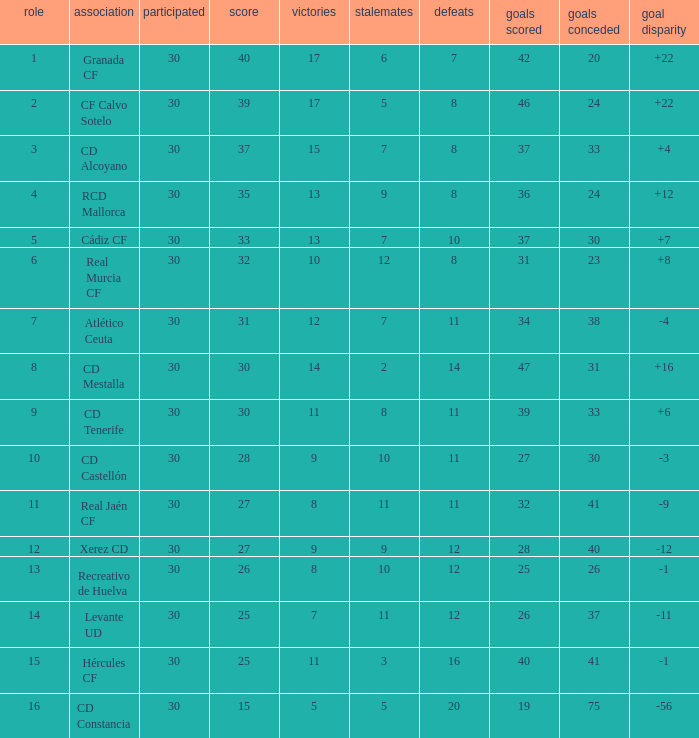I'm looking to parse the entire table for insights. Could you assist me with that? {'header': ['role', 'association', 'participated', 'score', 'victories', 'stalemates', 'defeats', 'goals scored', 'goals conceded', 'goal disparity'], 'rows': [['1', 'Granada CF', '30', '40', '17', '6', '7', '42', '20', '+22'], ['2', 'CF Calvo Sotelo', '30', '39', '17', '5', '8', '46', '24', '+22'], ['3', 'CD Alcoyano', '30', '37', '15', '7', '8', '37', '33', '+4'], ['4', 'RCD Mallorca', '30', '35', '13', '9', '8', '36', '24', '+12'], ['5', 'Cádiz CF', '30', '33', '13', '7', '10', '37', '30', '+7'], ['6', 'Real Murcia CF', '30', '32', '10', '12', '8', '31', '23', '+8'], ['7', 'Atlético Ceuta', '30', '31', '12', '7', '11', '34', '38', '-4'], ['8', 'CD Mestalla', '30', '30', '14', '2', '14', '47', '31', '+16'], ['9', 'CD Tenerife', '30', '30', '11', '8', '11', '39', '33', '+6'], ['10', 'CD Castellón', '30', '28', '9', '10', '11', '27', '30', '-3'], ['11', 'Real Jaén CF', '30', '27', '8', '11', '11', '32', '41', '-9'], ['12', 'Xerez CD', '30', '27', '9', '9', '12', '28', '40', '-12'], ['13', 'Recreativo de Huelva', '30', '26', '8', '10', '12', '25', '26', '-1'], ['14', 'Levante UD', '30', '25', '7', '11', '12', '26', '37', '-11'], ['15', 'Hércules CF', '30', '25', '11', '3', '16', '40', '41', '-1'], ['16', 'CD Constancia', '30', '15', '5', '5', '20', '19', '75', '-56']]} How many Wins have Goals against smaller than 30, and Goals for larger than 25, and Draws larger than 5? 3.0. 